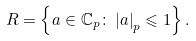Convert formula to latex. <formula><loc_0><loc_0><loc_500><loc_500>R = \left \{ a \in \mathbb { C } _ { p } \colon \left | a \right | _ { p } \leqslant 1 \right \} .</formula> 